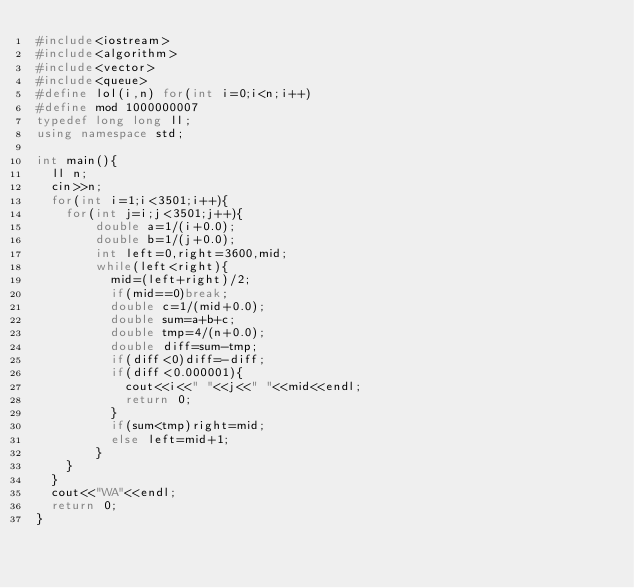<code> <loc_0><loc_0><loc_500><loc_500><_C++_>#include<iostream>
#include<algorithm>
#include<vector>
#include<queue>
#define lol(i,n) for(int i=0;i<n;i++)
#define mod 1000000007
typedef long long ll;
using namespace std;

int main(){
	ll n;
	cin>>n;
	for(int i=1;i<3501;i++){
		for(int j=i;j<3501;j++){
				double a=1/(i+0.0);
				double b=1/(j+0.0);
				int left=0,right=3600,mid;
				while(left<right){
					mid=(left+right)/2;
					if(mid==0)break;
					double c=1/(mid+0.0);
					double sum=a+b+c;
					double tmp=4/(n+0.0);
					double diff=sum-tmp;
					if(diff<0)diff=-diff;
					if(diff<0.000001){
						cout<<i<<" "<<j<<" "<<mid<<endl;
						return 0;
					}
					if(sum<tmp)right=mid;
					else left=mid+1;
				}
		}
	}
	cout<<"WA"<<endl;
	return 0;
}
</code> 